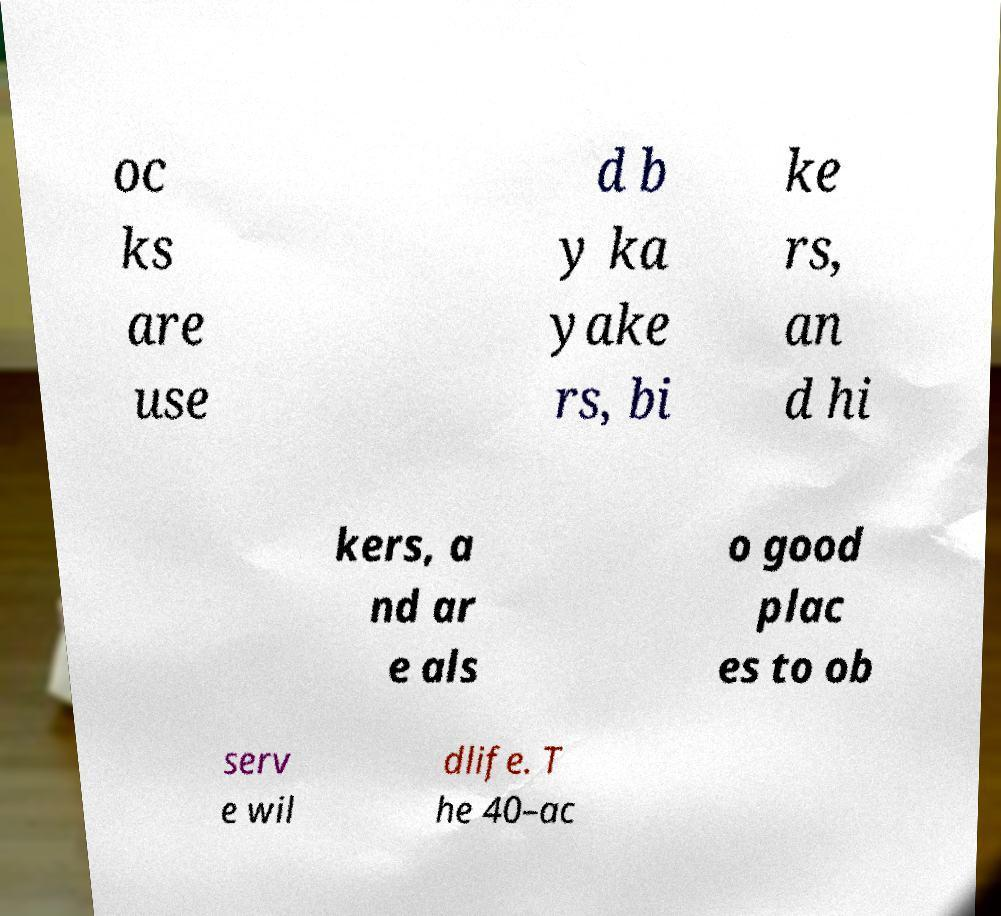For documentation purposes, I need the text within this image transcribed. Could you provide that? oc ks are use d b y ka yake rs, bi ke rs, an d hi kers, a nd ar e als o good plac es to ob serv e wil dlife. T he 40–ac 